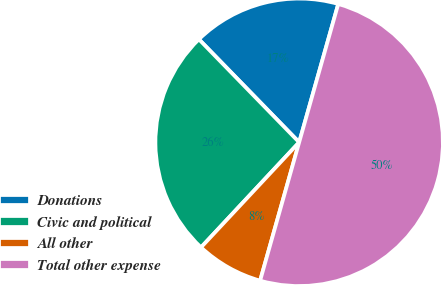Convert chart. <chart><loc_0><loc_0><loc_500><loc_500><pie_chart><fcel>Donations<fcel>Civic and political<fcel>All other<fcel>Total other expense<nl><fcel>16.67%<fcel>25.76%<fcel>7.58%<fcel>50.0%<nl></chart> 